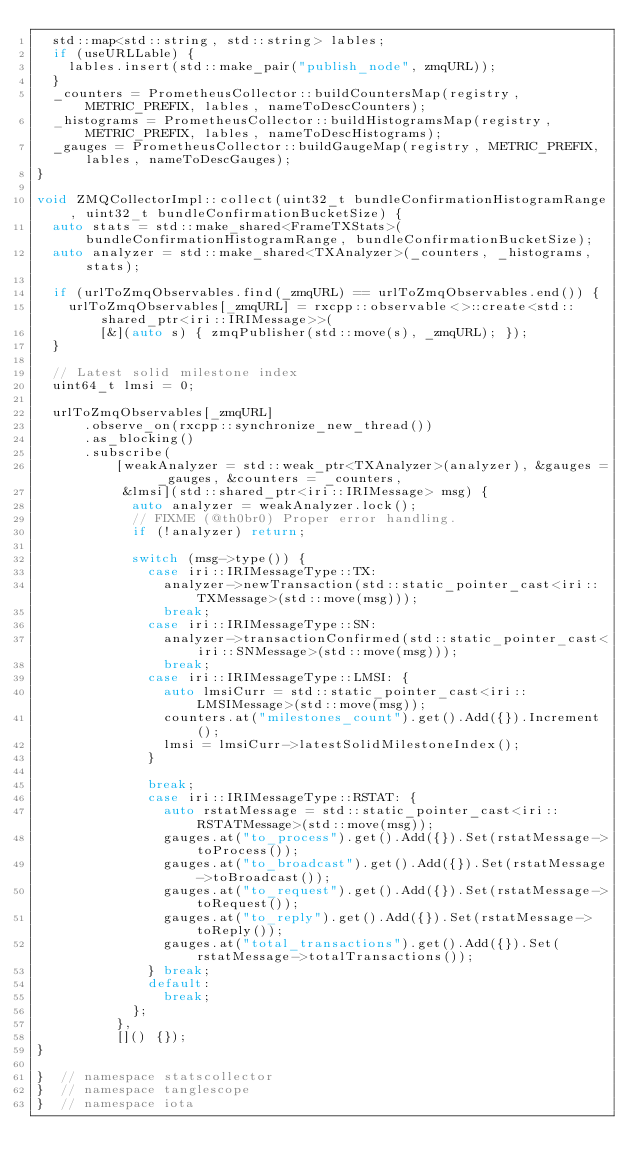<code> <loc_0><loc_0><loc_500><loc_500><_C++_>  std::map<std::string, std::string> lables;
  if (useURLLable) {
    lables.insert(std::make_pair("publish_node", zmqURL));
  }
  _counters = PrometheusCollector::buildCountersMap(registry, METRIC_PREFIX, lables, nameToDescCounters);
  _histograms = PrometheusCollector::buildHistogramsMap(registry, METRIC_PREFIX, lables, nameToDescHistograms);
  _gauges = PrometheusCollector::buildGaugeMap(registry, METRIC_PREFIX, lables, nameToDescGauges);
}

void ZMQCollectorImpl::collect(uint32_t bundleConfirmationHistogramRange, uint32_t bundleConfirmationBucketSize) {
  auto stats = std::make_shared<FrameTXStats>(bundleConfirmationHistogramRange, bundleConfirmationBucketSize);
  auto analyzer = std::make_shared<TXAnalyzer>(_counters, _histograms, stats);

  if (urlToZmqObservables.find(_zmqURL) == urlToZmqObservables.end()) {
    urlToZmqObservables[_zmqURL] = rxcpp::observable<>::create<std::shared_ptr<iri::IRIMessage>>(
        [&](auto s) { zmqPublisher(std::move(s), _zmqURL); });
  }

  // Latest solid milestone index
  uint64_t lmsi = 0;

  urlToZmqObservables[_zmqURL]
      .observe_on(rxcpp::synchronize_new_thread())
      .as_blocking()
      .subscribe(
          [weakAnalyzer = std::weak_ptr<TXAnalyzer>(analyzer), &gauges = _gauges, &counters = _counters,
           &lmsi](std::shared_ptr<iri::IRIMessage> msg) {
            auto analyzer = weakAnalyzer.lock();
            // FIXME (@th0br0) Proper error handling.
            if (!analyzer) return;

            switch (msg->type()) {
              case iri::IRIMessageType::TX:
                analyzer->newTransaction(std::static_pointer_cast<iri::TXMessage>(std::move(msg)));
                break;
              case iri::IRIMessageType::SN:
                analyzer->transactionConfirmed(std::static_pointer_cast<iri::SNMessage>(std::move(msg)));
                break;
              case iri::IRIMessageType::LMSI: {
                auto lmsiCurr = std::static_pointer_cast<iri::LMSIMessage>(std::move(msg));
                counters.at("milestones_count").get().Add({}).Increment();
                lmsi = lmsiCurr->latestSolidMilestoneIndex();
              }

              break;
              case iri::IRIMessageType::RSTAT: {
                auto rstatMessage = std::static_pointer_cast<iri::RSTATMessage>(std::move(msg));
                gauges.at("to_process").get().Add({}).Set(rstatMessage->toProcess());
                gauges.at("to_broadcast").get().Add({}).Set(rstatMessage->toBroadcast());
                gauges.at("to_request").get().Add({}).Set(rstatMessage->toRequest());
                gauges.at("to_reply").get().Add({}).Set(rstatMessage->toReply());
                gauges.at("total_transactions").get().Add({}).Set(rstatMessage->totalTransactions());
              } break;
              default:
                break;
            };
          },
          []() {});
}

}  // namespace statscollector
}  // namespace tanglescope
}  // namespace iota
</code> 